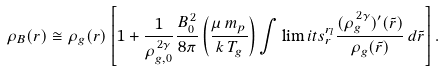Convert formula to latex. <formula><loc_0><loc_0><loc_500><loc_500>\rho _ { B } ( r ) \cong \rho _ { g } ( r ) \left [ 1 + \frac { 1 } { \rho _ { g , 0 } ^ { \, 2 \gamma } } \frac { B _ { 0 } ^ { \, 2 } } { 8 \pi } \left ( \frac { \mu \, m _ { p } } { k \, T _ { g } } \right ) \int \lim i t s _ { r } ^ { r _ { l } } \frac { ( \rho _ { g } ^ { \, 2 \gamma } ) ^ { \prime } ( \tilde { r } ) } { \rho _ { g } ( \tilde { r } ) } \, d \tilde { r } \right ] .</formula> 